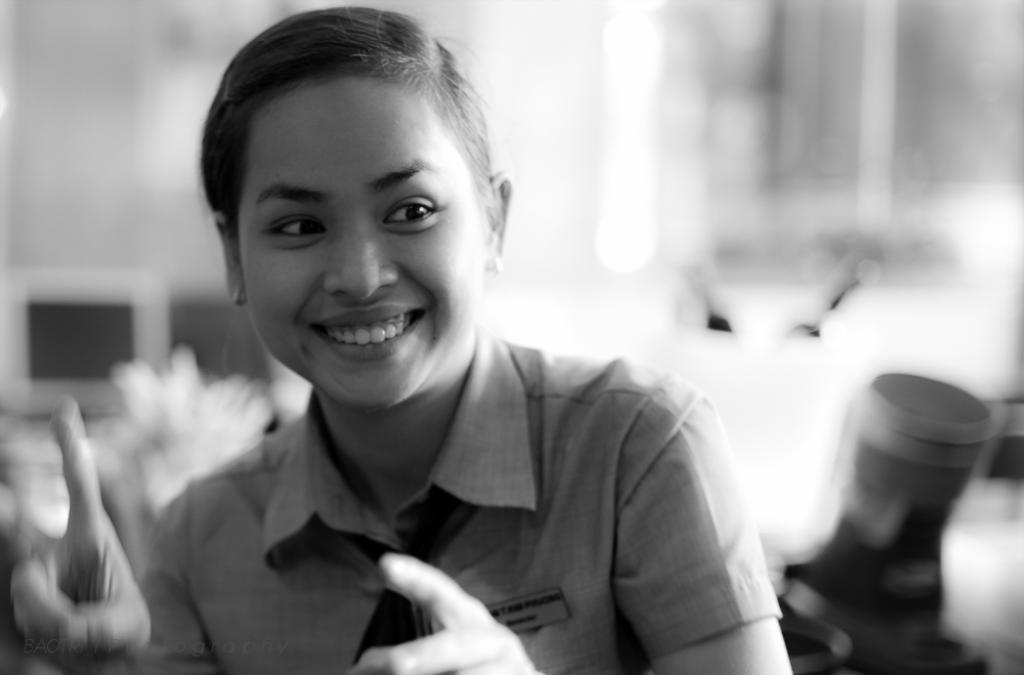Who is present in the image? There is a woman in the image. What is the woman's expression in the image? The woman is smiling in the image. Can you describe the background of the image? The background of the image is blurry. What type of division is being taught in the image? There is no indication of any division or teaching in the image; it features a woman smiling with a blurry background. 